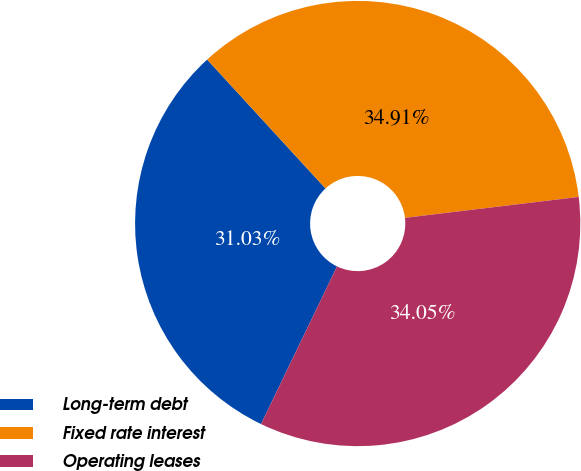<chart> <loc_0><loc_0><loc_500><loc_500><pie_chart><fcel>Long-term debt<fcel>Fixed rate interest<fcel>Operating leases<nl><fcel>31.03%<fcel>34.91%<fcel>34.05%<nl></chart> 